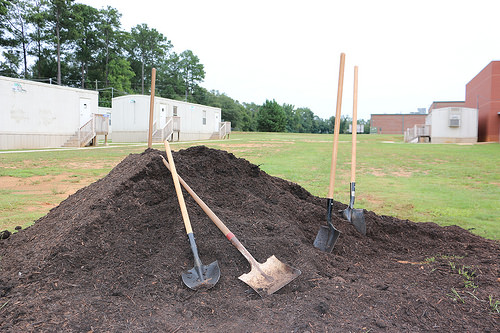<image>
Can you confirm if the shovel is in front of the dirt? Yes. The shovel is positioned in front of the dirt, appearing closer to the camera viewpoint. 